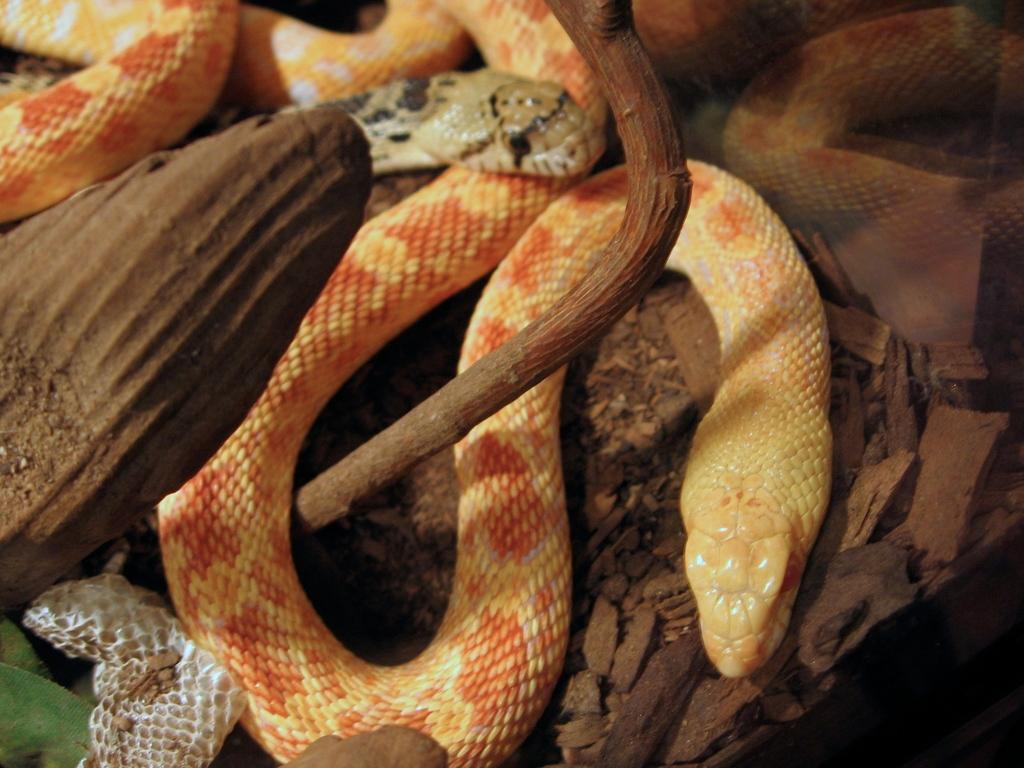What type of animals are present in the image? There are snakes in the image. What else can be seen in the image besides the snakes? There are stones in the image. What is the beggar doing in the image? There is no beggar present in the image. How do the snakes react to the recess in the image? There is no recess present in the image, and therefore no such reaction can be observed. 